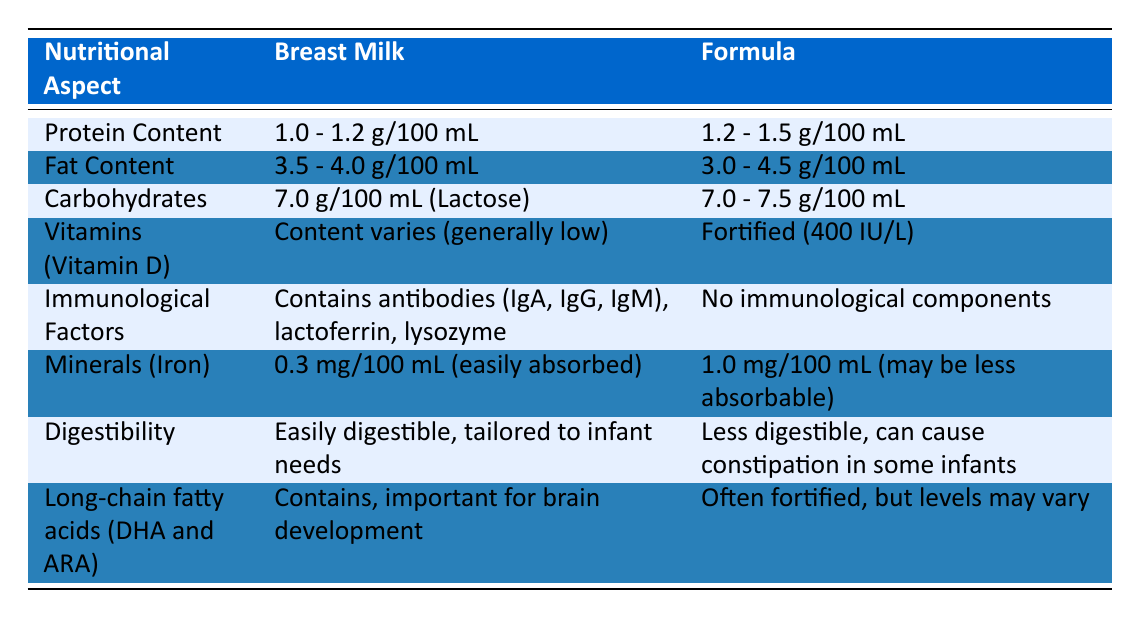What is the protein content in breast milk? The table indicates that the protein content in breast milk is between 1.0 and 1.2 g/100 mL.
Answer: 1.0 - 1.2 g/100 mL Does formula contain immunological factors? According to the table, formula does not contain any immunological components, while breast milk contains antibodies and other factors.
Answer: No What is the fat content range of formula? The table shows that the fat content in formula ranges from 3.0 to 4.5 g/100 mL.
Answer: 3.0 - 4.5 g/100 mL What is the difference in iron content between breast milk and formula? Breast milk has 0.3 mg/100 mL of iron, while formula has 1.0 mg/100 mL. The difference is 1.0 - 0.3 = 0.7 mg/100 mL.
Answer: 0.7 mg/100 mL Which nutrient is fortified in formula? The table specifies that formula is fortified with Vitamin D at 400 IU/L, while breast milk generally has low vitamin D content.
Answer: Vitamin D 